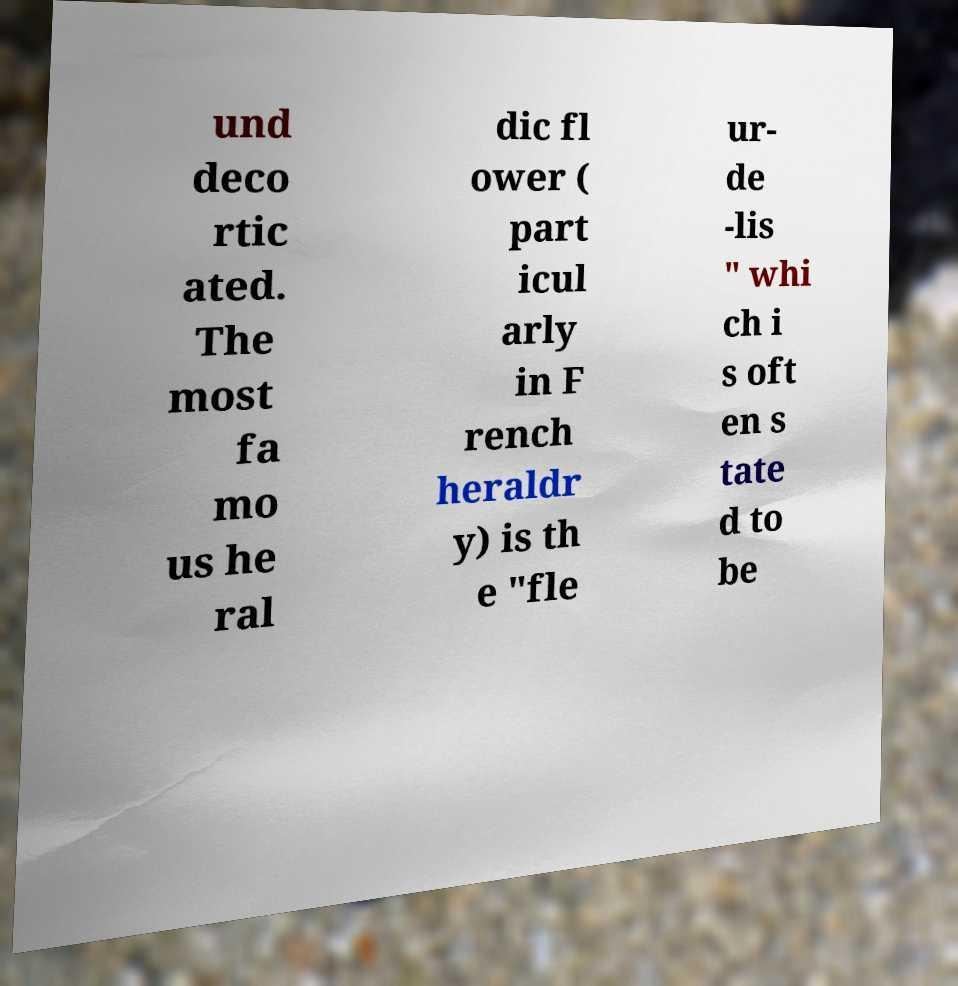Can you accurately transcribe the text from the provided image for me? und deco rtic ated. The most fa mo us he ral dic fl ower ( part icul arly in F rench heraldr y) is th e "fle ur- de -lis " whi ch i s oft en s tate d to be 